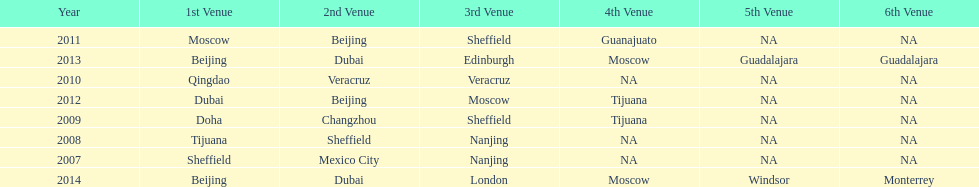In what year was the 3rd venue the same as 2011's 1st venue? 2012. 